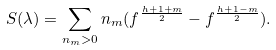Convert formula to latex. <formula><loc_0><loc_0><loc_500><loc_500>S ( \lambda ) = \sum _ { n _ { m } > 0 } n _ { m } ( f ^ { \frac { h + 1 + m } { 2 } } - f ^ { \frac { h + 1 - m } { 2 } } ) .</formula> 